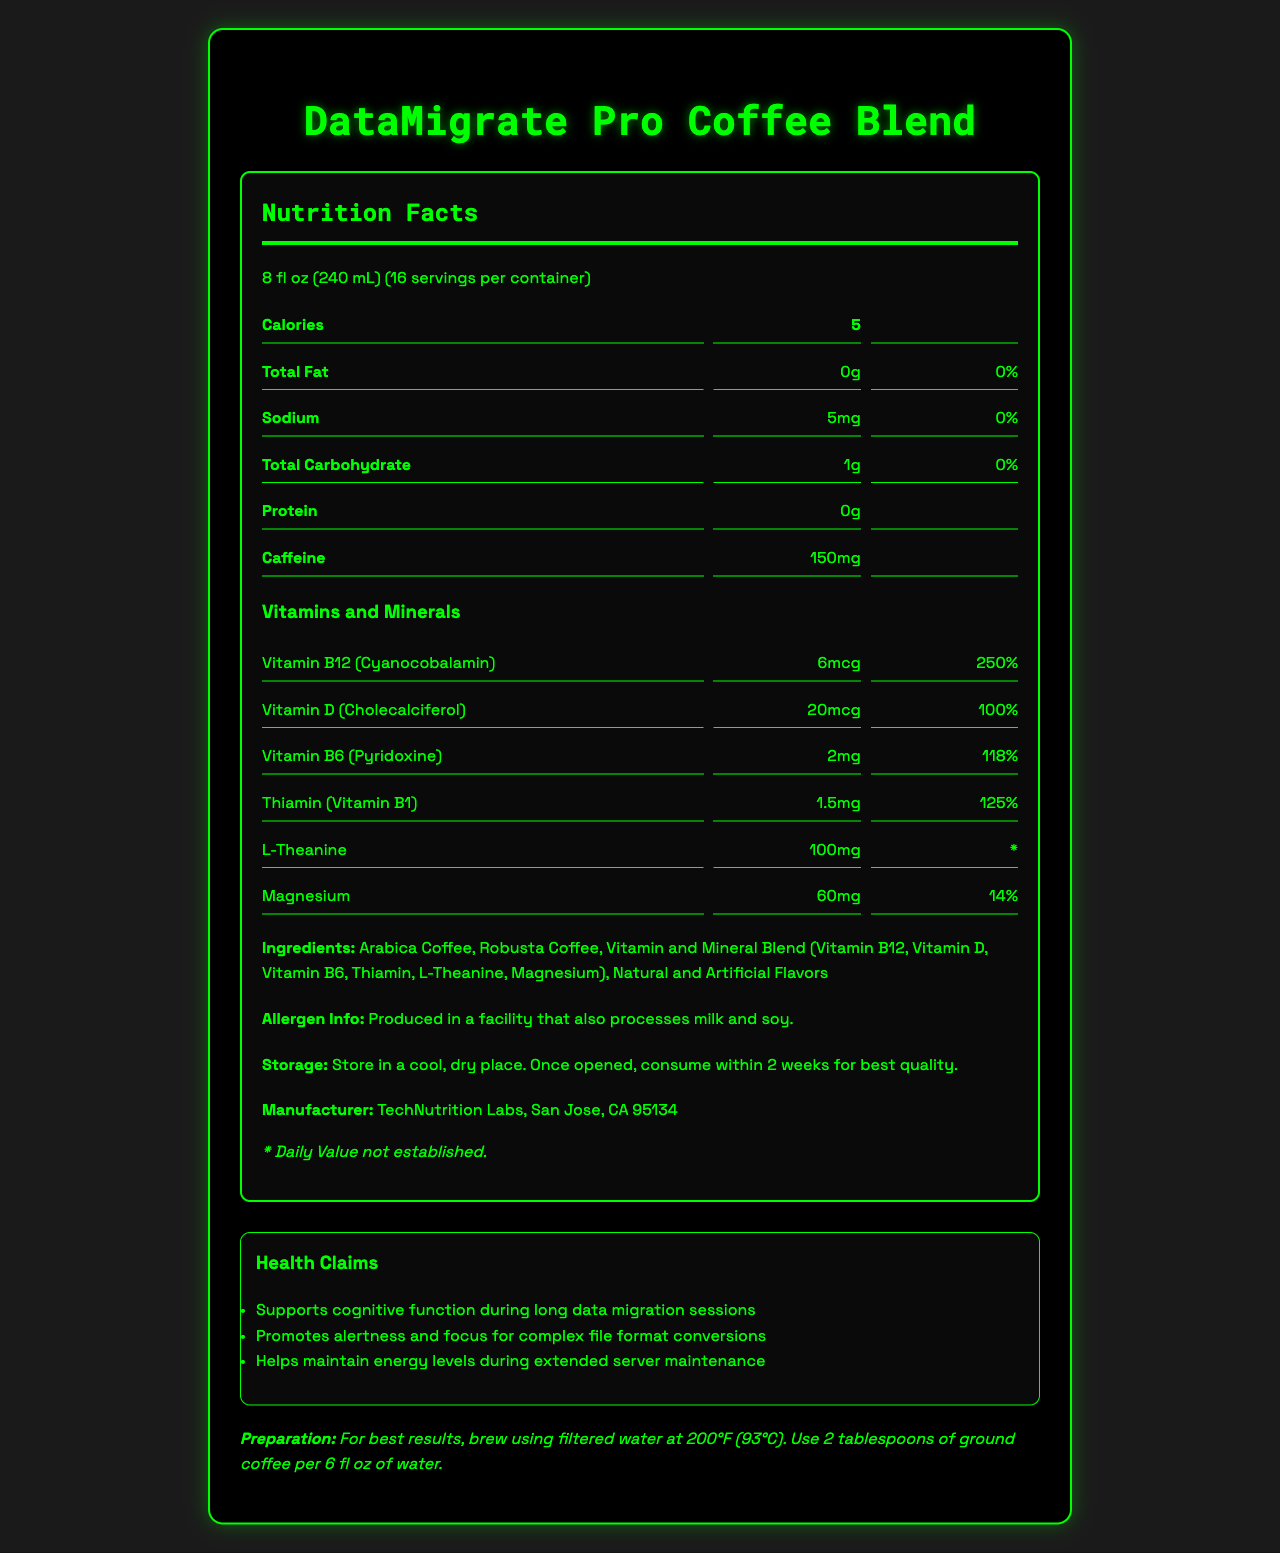what is the serving size of DataMigrate Pro Coffee Blend? The serving size is clearly indicated at the top of the nutrition facts label as "8 fl oz (240 mL)".
Answer: 8 fl oz (240 mL) how many servings are there per container? The document states "Servings Per Container: 16".
Answer: 16 how much caffeine does one serving contain? The amount of caffeine per serving is displayed in the nutrition facts under the "Caffeine" section.
Answer: 150mg what is the calorie content per serving? The calorie content per serving is shown at the top of the nutrition facts label as "Calories: 5".
Answer: 5 which vitamins and minerals are included in the coffee blend? The document lists each vitamin and mineral under the "Vitamins and Minerals" section.
Answer: Vitamin B12, Vitamin D, Vitamin B6, Thiamin, L-Theanine, Magnesium what are the ingredients of DataMigrate Pro Coffee Blend? The ingredients are listed under the "Ingredients" section.
Answer: Arabica Coffee, Robusta Coffee, Vitamin and Mineral Blend (Vitamin B12, Vitamin D, Vitamin B6, Thiamin, L-Theanine, Magnesium), Natural and Artificial Flavors how should I store the coffee after opening? The storage instructions are mentioned under the "Storage" section.
Answer: Store in a cool, dry place. Once opened, consume within 2 weeks for best quality. who is the manufacturer of the coffee blend? The manufacturer information is located at the bottom of the document.
Answer: TechNutrition Labs, San Jose, CA 95134 which statement is true about the health claims of DataMigrate Pro Coffee Blend? 
A. Helps in weight loss
B. Supports cognitive function during long data migration sessions
C. Reduces cholesterol levels
D. Treats anxiety The health claims section lists "Supports cognitive function during long data migration sessions" as one of its claims.
Answer: B what is the daily value percentage of Vitamin B12 per serving? 
A. 100%
B. 200%
C. 250%
D. 300% The document indicates that Vitamin B12 (Cyanocobalamin) has a daily value of 250%.
Answer: C Is there any allergen information provided for the coffee blend? The allergen information states that the product is produced in a facility that also processes milk and soy.
Answer: Yes does the coffee blend contain any protein? The nutrition facts label shows "Protein: 0g".
Answer: No summarize the main nutritional and functional highlights of DataMigrate Pro Coffee Blend. The summary encompasses the primary nutritional values, health claims, ingredients, and instructions provided in the document.
Answer: The DataMigrate Pro Coffee Blend offers a low-calorie coffee option with high caffeine content (150mg per serving) and is enriched with vitamins and minerals like Vitamin B12, Vitamin D, and Magnesium. It supports cognitive function, promotes alertness and focus, and helps maintain energy levels. The blend includes Arabica and Robusta beans, natural and artificial flavors, and specific storage and preparation instructions. how many grams of total fat are in one serving? The total fat amount per serving is listed in the nutrition facts as "Total Fat: 0g".
Answer: 0g how much sodium does the coffee blend contain per serving? The sodium content per serving is indicated in the nutrition facts.
Answer: 5mg is the daily value percentage for L-Theanine provided? The document states "* Daily Value not established" for L-Theanine.
Answer: No does the coffee blend contain any sugars? The nutrition facts listing doesn't specify any information about sugar content.
Answer: Cannot be determined 